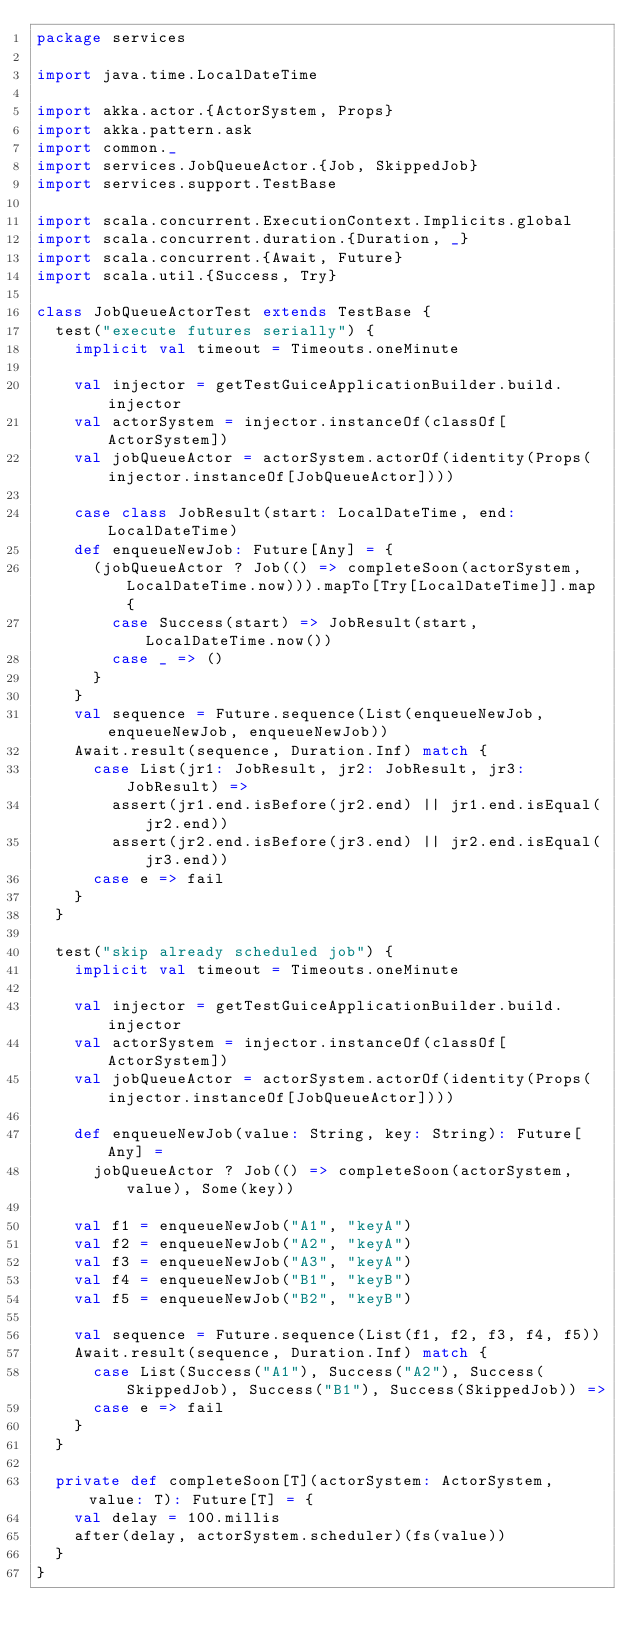<code> <loc_0><loc_0><loc_500><loc_500><_Scala_>package services

import java.time.LocalDateTime

import akka.actor.{ActorSystem, Props}
import akka.pattern.ask
import common._
import services.JobQueueActor.{Job, SkippedJob}
import services.support.TestBase

import scala.concurrent.ExecutionContext.Implicits.global
import scala.concurrent.duration.{Duration, _}
import scala.concurrent.{Await, Future}
import scala.util.{Success, Try}

class JobQueueActorTest extends TestBase {
  test("execute futures serially") {
    implicit val timeout = Timeouts.oneMinute

    val injector = getTestGuiceApplicationBuilder.build.injector
    val actorSystem = injector.instanceOf(classOf[ActorSystem])
    val jobQueueActor = actorSystem.actorOf(identity(Props(injector.instanceOf[JobQueueActor])))

    case class JobResult(start: LocalDateTime, end: LocalDateTime)
    def enqueueNewJob: Future[Any] = {
      (jobQueueActor ? Job(() => completeSoon(actorSystem, LocalDateTime.now))).mapTo[Try[LocalDateTime]].map {
        case Success(start) => JobResult(start, LocalDateTime.now())
        case _ => ()
      }
    }
    val sequence = Future.sequence(List(enqueueNewJob, enqueueNewJob, enqueueNewJob))
    Await.result(sequence, Duration.Inf) match {
      case List(jr1: JobResult, jr2: JobResult, jr3: JobResult) =>
        assert(jr1.end.isBefore(jr2.end) || jr1.end.isEqual(jr2.end))
        assert(jr2.end.isBefore(jr3.end) || jr2.end.isEqual(jr3.end))
      case e => fail
    }
  }

  test("skip already scheduled job") {
    implicit val timeout = Timeouts.oneMinute

    val injector = getTestGuiceApplicationBuilder.build.injector
    val actorSystem = injector.instanceOf(classOf[ActorSystem])
    val jobQueueActor = actorSystem.actorOf(identity(Props(injector.instanceOf[JobQueueActor])))

    def enqueueNewJob(value: String, key: String): Future[Any] =
      jobQueueActor ? Job(() => completeSoon(actorSystem, value), Some(key))

    val f1 = enqueueNewJob("A1", "keyA")
    val f2 = enqueueNewJob("A2", "keyA")
    val f3 = enqueueNewJob("A3", "keyA")
    val f4 = enqueueNewJob("B1", "keyB")
    val f5 = enqueueNewJob("B2", "keyB")

    val sequence = Future.sequence(List(f1, f2, f3, f4, f5))
    Await.result(sequence, Duration.Inf) match {
      case List(Success("A1"), Success("A2"), Success(SkippedJob), Success("B1"), Success(SkippedJob)) =>
      case e => fail
    }
  }

  private def completeSoon[T](actorSystem: ActorSystem, value: T): Future[T] = {
    val delay = 100.millis
    after(delay, actorSystem.scheduler)(fs(value))
  }
}
</code> 